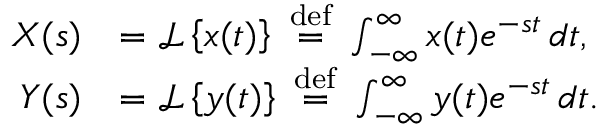<formula> <loc_0><loc_0><loc_500><loc_500>{ \begin{array} { r l } { X ( s ) } & { = { \mathcal { L } } \left \{ x ( t ) \right \} \ { \stackrel { d e f } { = } } \ \int _ { - \infty } ^ { \infty } x ( t ) e ^ { - s t } \, d t , } \\ { Y ( s ) } & { = { \mathcal { L } } \left \{ y ( t ) \right \} \ { \stackrel { d e f } { = } } \ \int _ { - \infty } ^ { \infty } y ( t ) e ^ { - s t } \, d t . } \end{array} }</formula> 